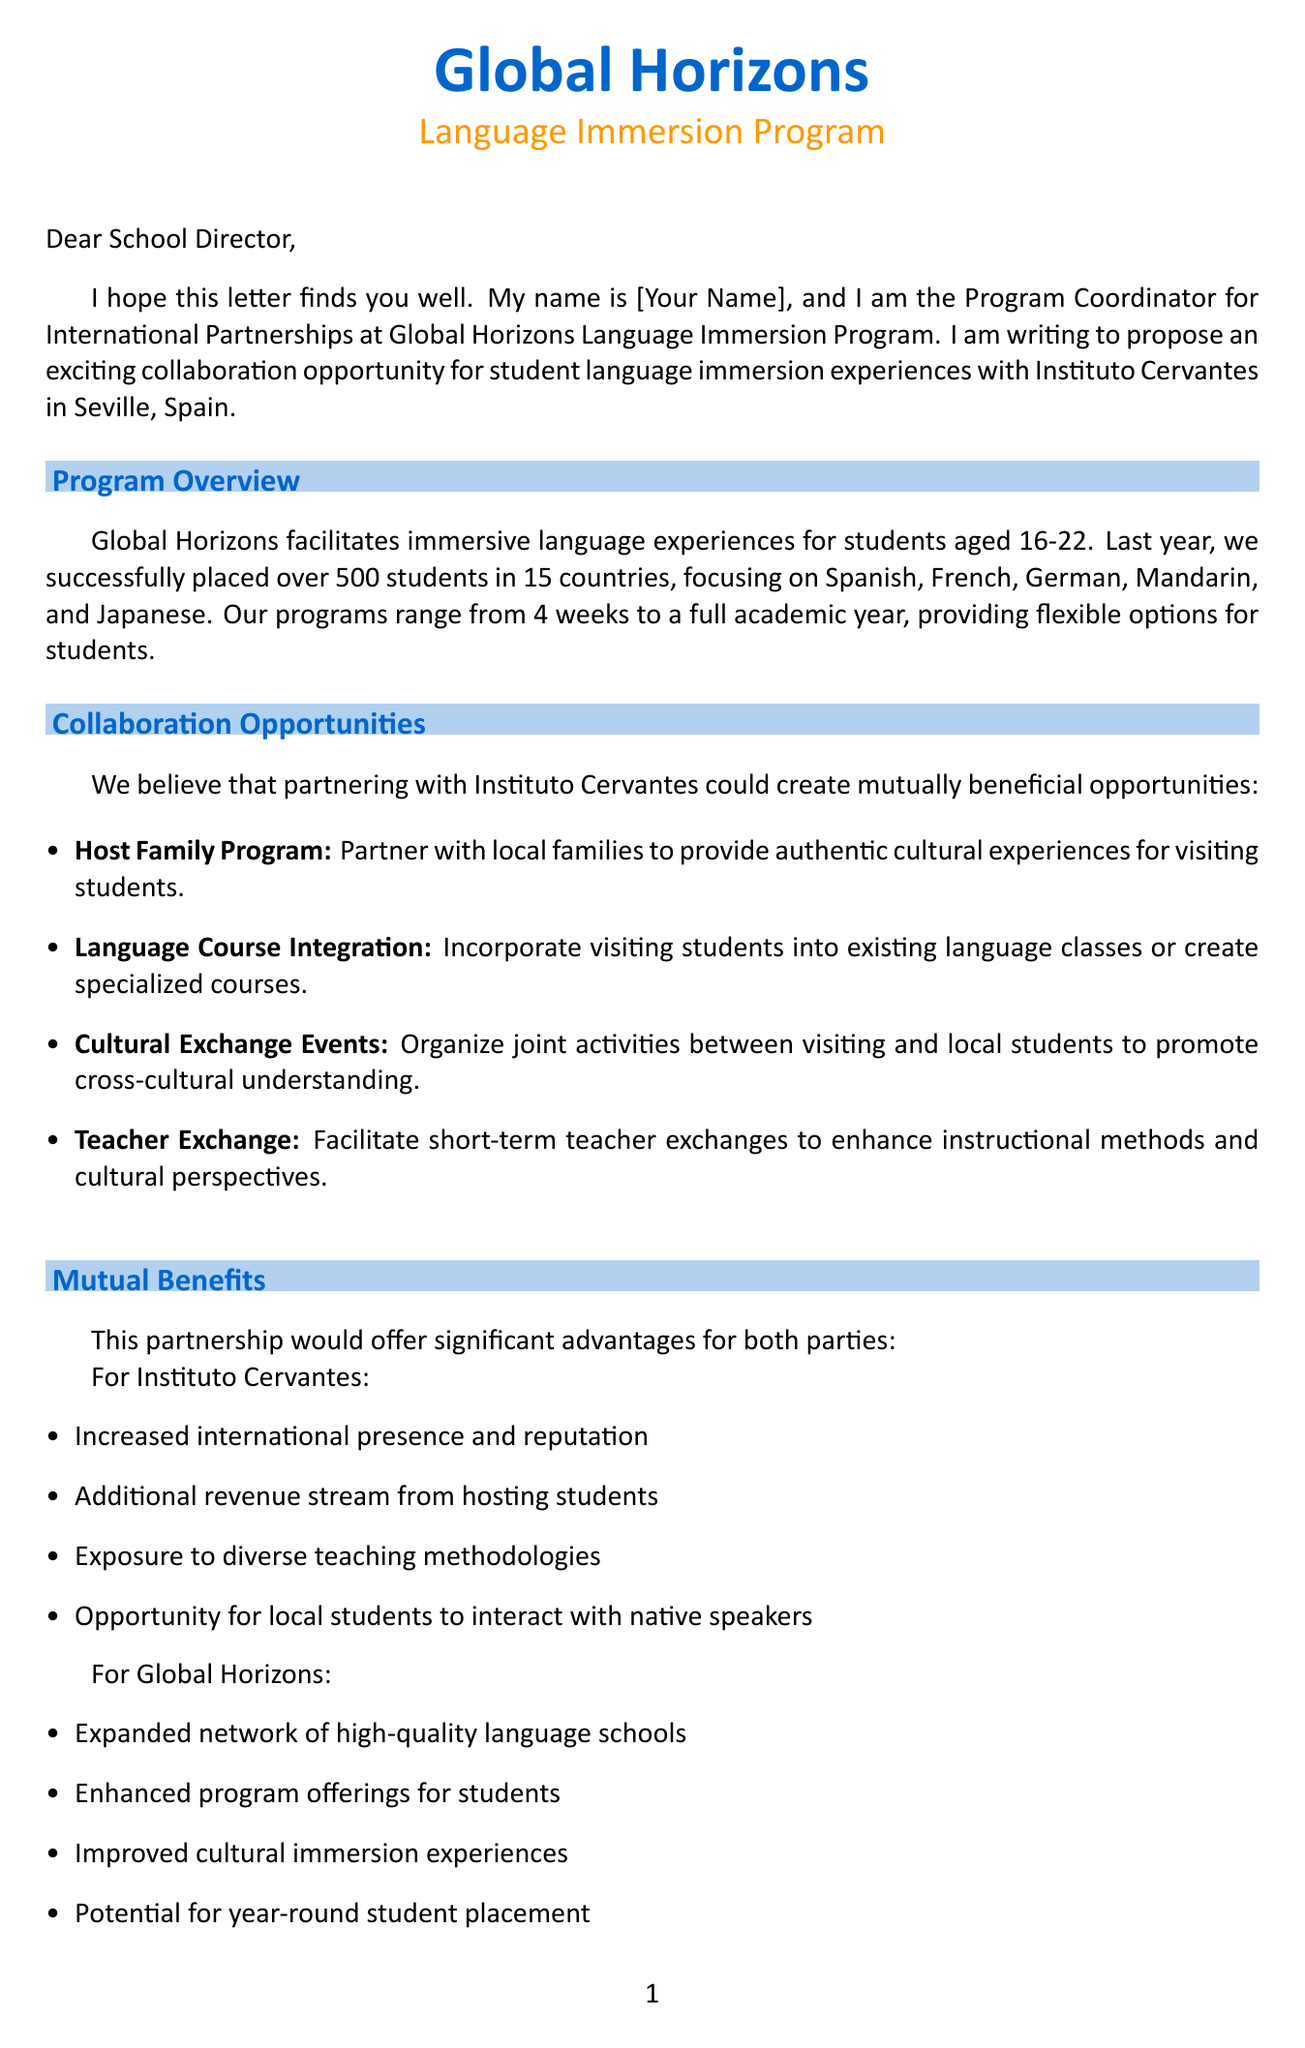what is the name of the program proposing the collaboration? The program proposing the collaboration is mentioned in the introduction of the letter.
Answer: Global Horizons Language Immersion Program what is the location of Instituto Cervantes? The location of Instituto Cervantes is indicated in the specific school details.
Answer: Seville, Spain how many students were successfully placed in the last year? The document states the number of students placed, indicating the program's reach.
Answer: 500+ what is one type of collaboration opportunity mentioned? The letter lists various collaboration opportunities within the body section, highlighting options for partnership.
Answer: Host Family Program how long is the duration of programs offered? The document specifies the range of program durations available for students.
Answer: 4 weeks to full academic year what is one mutual benefit for Global Horizons? The mutual benefits section outlines what Global Horizons would gain from the partnership.
Answer: Expanded network of high-quality language schools when is the initial discussion proposed to take place? The proposed timeline section includes a specific time frame for the initial discussion.
Answer: Within the next 2 weeks what is included in the proposed next steps? The next steps section lists actions to take in order to advance the partnership proposal.
Answer: Schedule a video call to discuss the proposal in detail what is the primary purpose of the letter? The overall aim of the letter is stated at the beginning, indicating the intent behind the communication.
Answer: Propose a collaboration for student language immersion experiences 